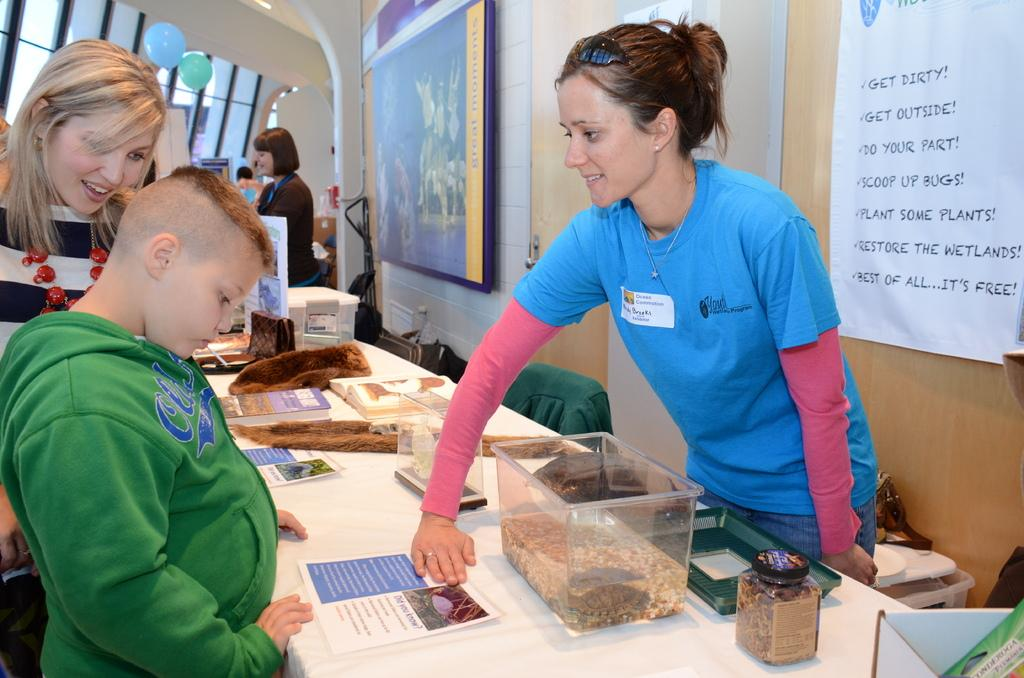What can be seen in the image involving people? There are people standing in the image. What object is present in the image that people might gather around? There is a table in the image. What items are on the table in the image? Papers and boxes are on the table in the image. What can be seen in the background of the image? There is a wall in the background of the image. What is on the wall in the background? Posters are on the wall in the background. How many pieces of art are displayed on the table in the image? There is no art displayed on the table in the image; it contains papers and boxes. What type of parcel is being delivered to the people in the image? There is no parcel being delivered in the image; it only shows people standing near a table with papers and boxes. 